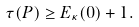Convert formula to latex. <formula><loc_0><loc_0><loc_500><loc_500>\tau ( P ) \geq E _ { \kappa } ( 0 ) + 1 .</formula> 